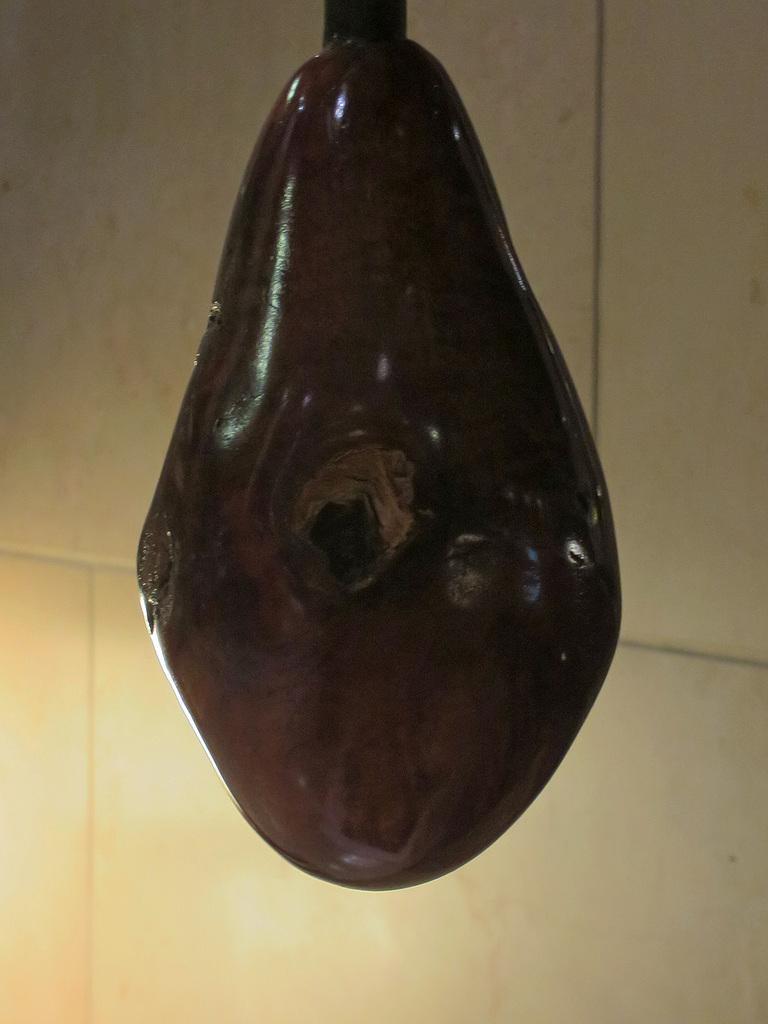How would you summarize this image in a sentence or two? In this picture we can observe a ceramic material which is in brown color. In the background there is a wall which is in white color. 